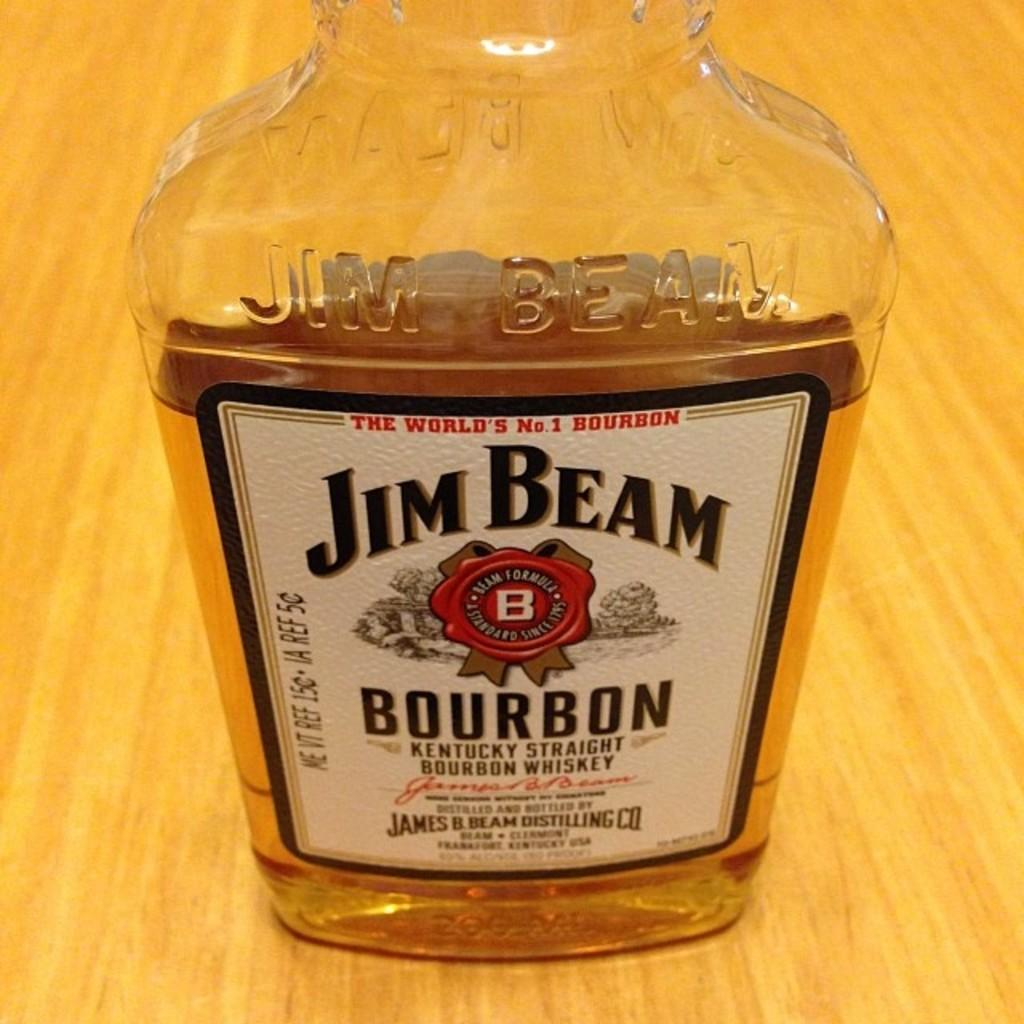<image>
Create a compact narrative representing the image presented. A bottle of Jim Bean Bourbon is by itself on a table. 